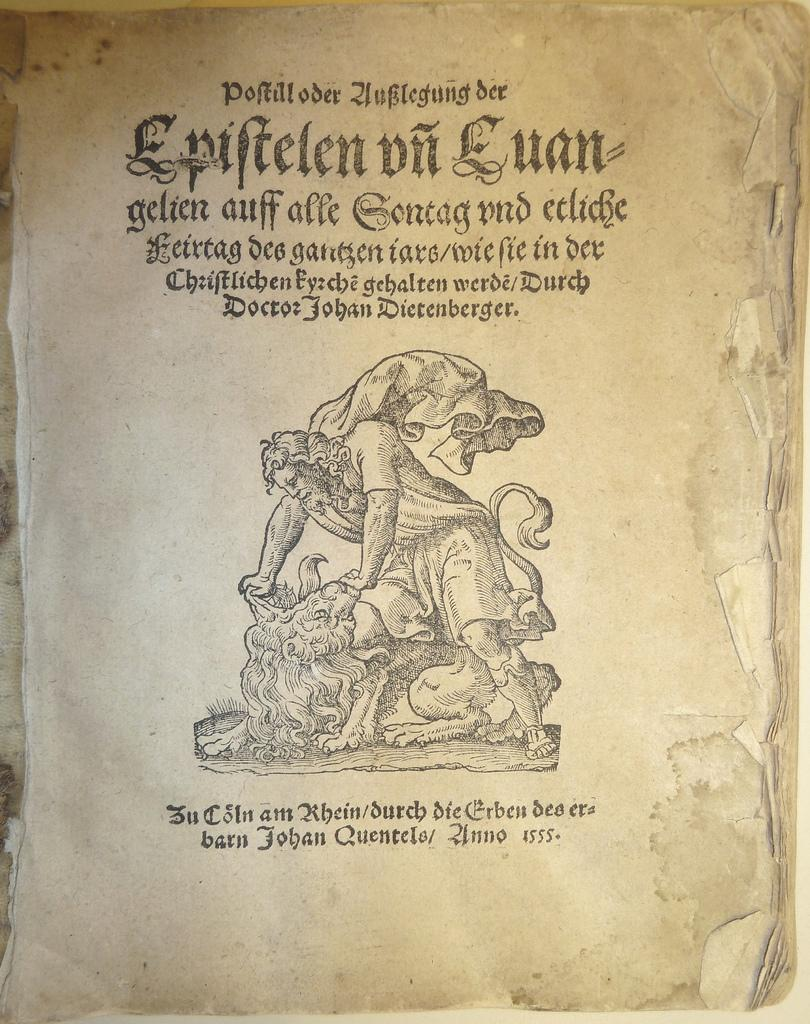<image>
Describe the image concisely. A page from an old book that says Doctor Johan Dietenberger right on top of the drawn figure. 